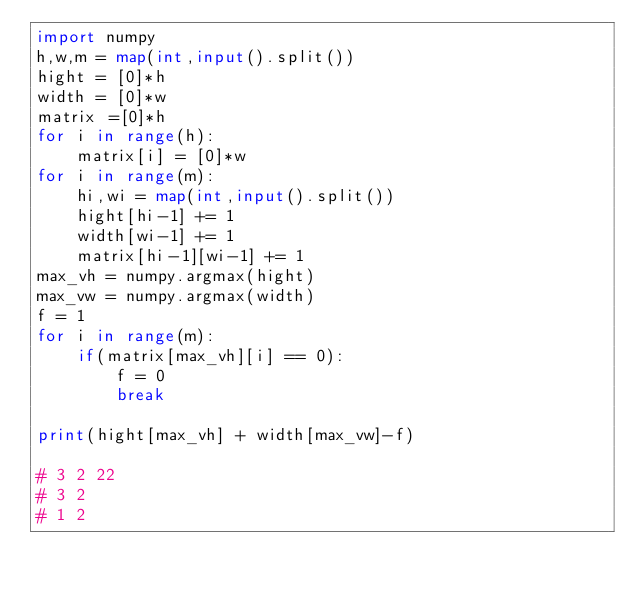Convert code to text. <code><loc_0><loc_0><loc_500><loc_500><_Python_>import numpy
h,w,m = map(int,input().split())
hight = [0]*h
width = [0]*w
matrix =[0]*h
for i in range(h):
    matrix[i] = [0]*w
for i in range(m):
    hi,wi = map(int,input().split())
    hight[hi-1] += 1
    width[wi-1] += 1
    matrix[hi-1][wi-1] += 1
max_vh = numpy.argmax(hight)
max_vw = numpy.argmax(width)
f = 1
for i in range(m):
    if(matrix[max_vh][i] == 0):
        f = 0
        break
 
print(hight[max_vh] + width[max_vw]-f)

# 3 2 22
# 3 2
# 1 2

</code> 